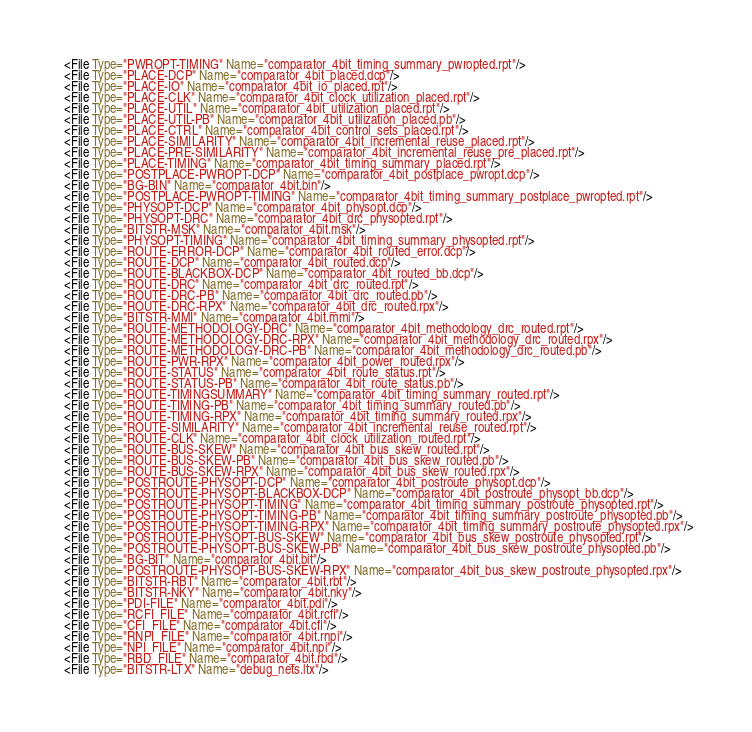<code> <loc_0><loc_0><loc_500><loc_500><_XML_>  <File Type="PWROPT-TIMING" Name="comparator_4bit_timing_summary_pwropted.rpt"/>
  <File Type="PLACE-DCP" Name="comparator_4bit_placed.dcp"/>
  <File Type="PLACE-IO" Name="comparator_4bit_io_placed.rpt"/>
  <File Type="PLACE-CLK" Name="comparator_4bit_clock_utilization_placed.rpt"/>
  <File Type="PLACE-UTIL" Name="comparator_4bit_utilization_placed.rpt"/>
  <File Type="PLACE-UTIL-PB" Name="comparator_4bit_utilization_placed.pb"/>
  <File Type="PLACE-CTRL" Name="comparator_4bit_control_sets_placed.rpt"/>
  <File Type="PLACE-SIMILARITY" Name="comparator_4bit_incremental_reuse_placed.rpt"/>
  <File Type="PLACE-PRE-SIMILARITY" Name="comparator_4bit_incremental_reuse_pre_placed.rpt"/>
  <File Type="PLACE-TIMING" Name="comparator_4bit_timing_summary_placed.rpt"/>
  <File Type="POSTPLACE-PWROPT-DCP" Name="comparator_4bit_postplace_pwropt.dcp"/>
  <File Type="BG-BIN" Name="comparator_4bit.bin"/>
  <File Type="POSTPLACE-PWROPT-TIMING" Name="comparator_4bit_timing_summary_postplace_pwropted.rpt"/>
  <File Type="PHYSOPT-DCP" Name="comparator_4bit_physopt.dcp"/>
  <File Type="PHYSOPT-DRC" Name="comparator_4bit_drc_physopted.rpt"/>
  <File Type="BITSTR-MSK" Name="comparator_4bit.msk"/>
  <File Type="PHYSOPT-TIMING" Name="comparator_4bit_timing_summary_physopted.rpt"/>
  <File Type="ROUTE-ERROR-DCP" Name="comparator_4bit_routed_error.dcp"/>
  <File Type="ROUTE-DCP" Name="comparator_4bit_routed.dcp"/>
  <File Type="ROUTE-BLACKBOX-DCP" Name="comparator_4bit_routed_bb.dcp"/>
  <File Type="ROUTE-DRC" Name="comparator_4bit_drc_routed.rpt"/>
  <File Type="ROUTE-DRC-PB" Name="comparator_4bit_drc_routed.pb"/>
  <File Type="ROUTE-DRC-RPX" Name="comparator_4bit_drc_routed.rpx"/>
  <File Type="BITSTR-MMI" Name="comparator_4bit.mmi"/>
  <File Type="ROUTE-METHODOLOGY-DRC" Name="comparator_4bit_methodology_drc_routed.rpt"/>
  <File Type="ROUTE-METHODOLOGY-DRC-RPX" Name="comparator_4bit_methodology_drc_routed.rpx"/>
  <File Type="ROUTE-METHODOLOGY-DRC-PB" Name="comparator_4bit_methodology_drc_routed.pb"/>
  <File Type="ROUTE-PWR-RPX" Name="comparator_4bit_power_routed.rpx"/>
  <File Type="ROUTE-STATUS" Name="comparator_4bit_route_status.rpt"/>
  <File Type="ROUTE-STATUS-PB" Name="comparator_4bit_route_status.pb"/>
  <File Type="ROUTE-TIMINGSUMMARY" Name="comparator_4bit_timing_summary_routed.rpt"/>
  <File Type="ROUTE-TIMING-PB" Name="comparator_4bit_timing_summary_routed.pb"/>
  <File Type="ROUTE-TIMING-RPX" Name="comparator_4bit_timing_summary_routed.rpx"/>
  <File Type="ROUTE-SIMILARITY" Name="comparator_4bit_incremental_reuse_routed.rpt"/>
  <File Type="ROUTE-CLK" Name="comparator_4bit_clock_utilization_routed.rpt"/>
  <File Type="ROUTE-BUS-SKEW" Name="comparator_4bit_bus_skew_routed.rpt"/>
  <File Type="ROUTE-BUS-SKEW-PB" Name="comparator_4bit_bus_skew_routed.pb"/>
  <File Type="ROUTE-BUS-SKEW-RPX" Name="comparator_4bit_bus_skew_routed.rpx"/>
  <File Type="POSTROUTE-PHYSOPT-DCP" Name="comparator_4bit_postroute_physopt.dcp"/>
  <File Type="POSTROUTE-PHYSOPT-BLACKBOX-DCP" Name="comparator_4bit_postroute_physopt_bb.dcp"/>
  <File Type="POSTROUTE-PHYSOPT-TIMING" Name="comparator_4bit_timing_summary_postroute_physopted.rpt"/>
  <File Type="POSTROUTE-PHYSOPT-TIMING-PB" Name="comparator_4bit_timing_summary_postroute_physopted.pb"/>
  <File Type="POSTROUTE-PHYSOPT-TIMING-RPX" Name="comparator_4bit_timing_summary_postroute_physopted.rpx"/>
  <File Type="POSTROUTE-PHYSOPT-BUS-SKEW" Name="comparator_4bit_bus_skew_postroute_physopted.rpt"/>
  <File Type="POSTROUTE-PHYSOPT-BUS-SKEW-PB" Name="comparator_4bit_bus_skew_postroute_physopted.pb"/>
  <File Type="BG-BIT" Name="comparator_4bit.bit"/>
  <File Type="POSTROUTE-PHYSOPT-BUS-SKEW-RPX" Name="comparator_4bit_bus_skew_postroute_physopted.rpx"/>
  <File Type="BITSTR-RBT" Name="comparator_4bit.rbt"/>
  <File Type="BITSTR-NKY" Name="comparator_4bit.nky"/>
  <File Type="PDI-FILE" Name="comparator_4bit.pdi"/>
  <File Type="RCFI_FILE" Name="comparator_4bit.rcfi"/>
  <File Type="CFI_FILE" Name="comparator_4bit.cfi"/>
  <File Type="RNPI_FILE" Name="comparator_4bit.rnpi"/>
  <File Type="NPI_FILE" Name="comparator_4bit.npi"/>
  <File Type="RBD_FILE" Name="comparator_4bit.rbd"/>
  <File Type="BITSTR-LTX" Name="debug_nets.ltx"/></code> 